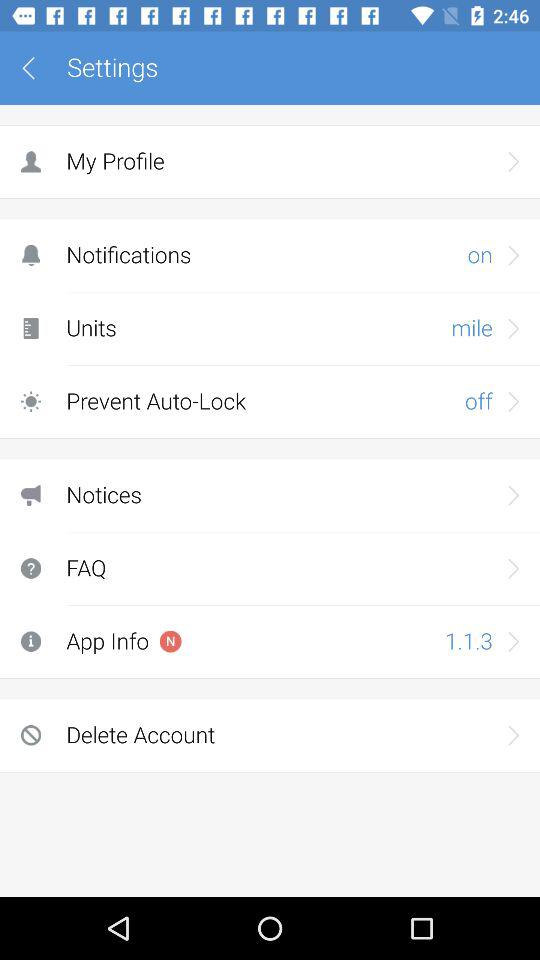Which version of the application is used? The used version of the application is 1.1.3. 